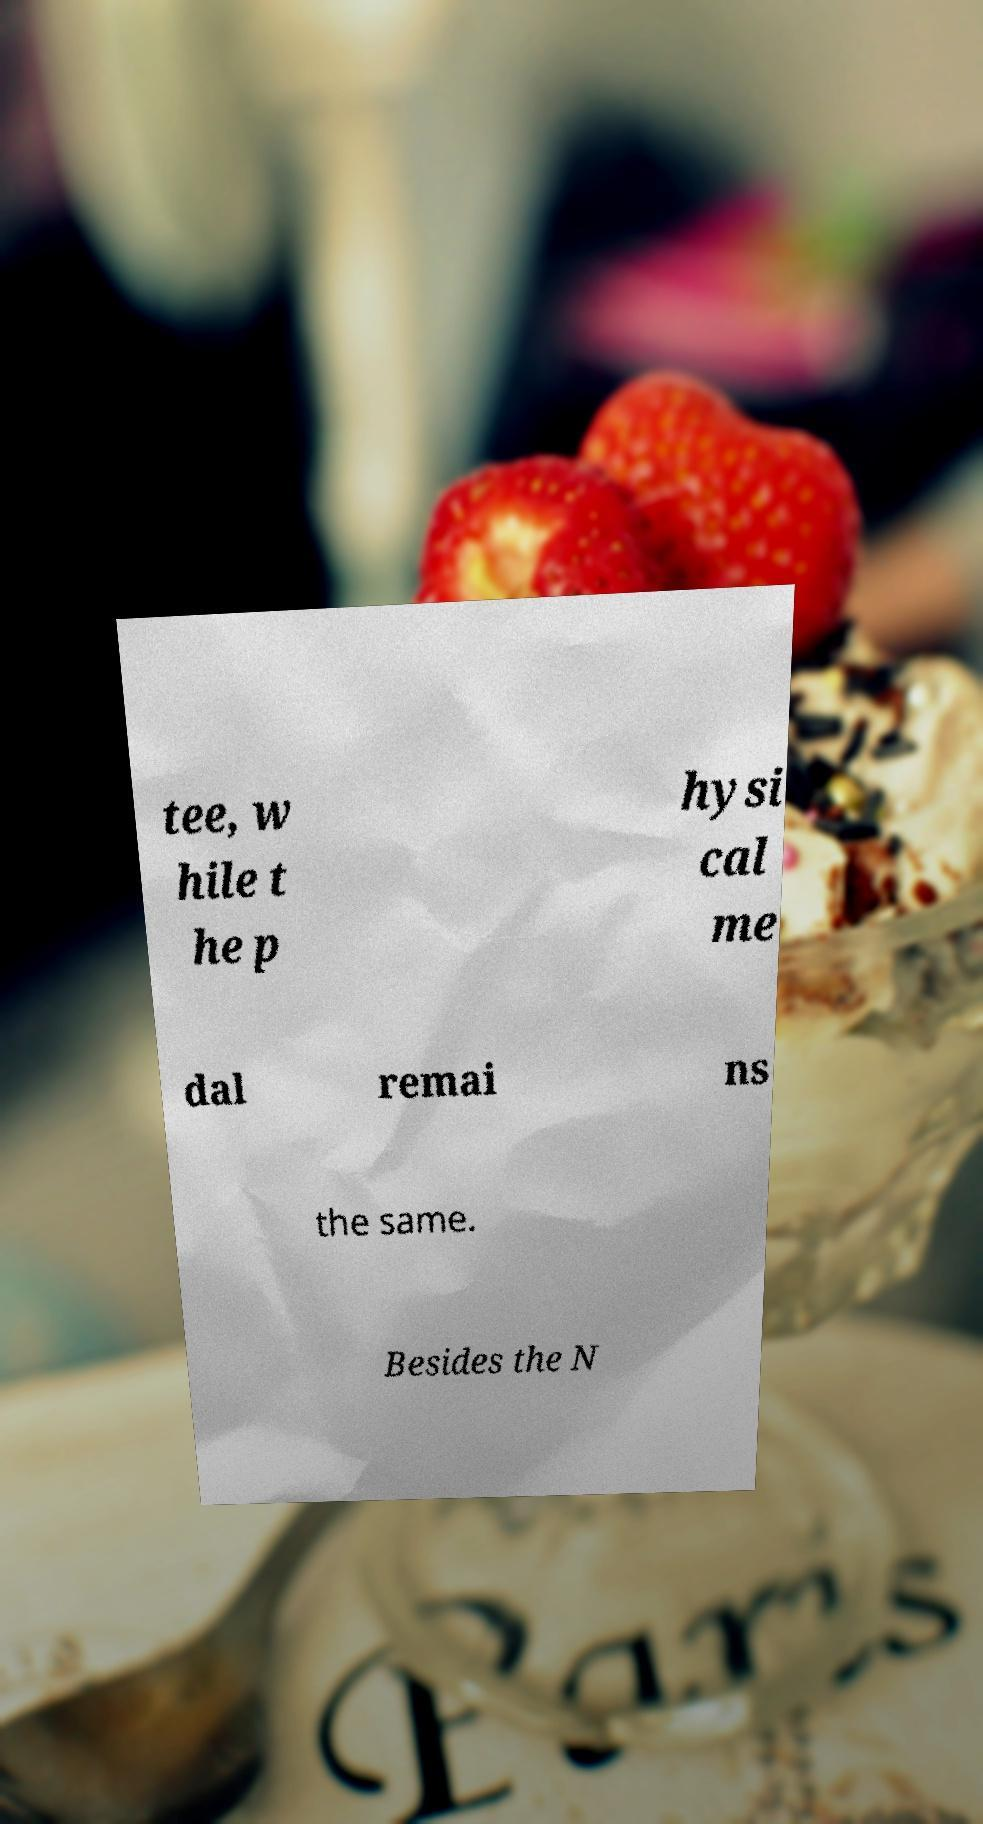What messages or text are displayed in this image? I need them in a readable, typed format. tee, w hile t he p hysi cal me dal remai ns the same. Besides the N 